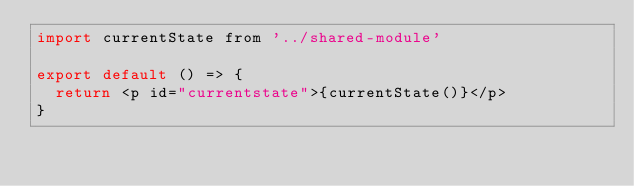Convert code to text. <code><loc_0><loc_0><loc_500><loc_500><_JavaScript_>import currentState from '../shared-module'

export default () => {
  return <p id="currentstate">{currentState()}</p>
}
</code> 